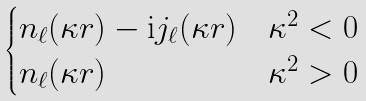Convert formula to latex. <formula><loc_0><loc_0><loc_500><loc_500>\begin{cases} n _ { \ell } ( \kappa r ) - \text {i} j _ { \ell } ( \kappa r ) & \kappa ^ { 2 } < 0 \\ n _ { \ell } ( \kappa r ) & \kappa ^ { 2 } > 0 \\ \end{cases}</formula> 